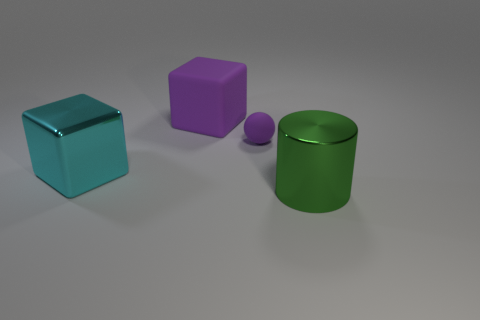What size is the cube that is the same color as the small matte object?
Your answer should be very brief. Large. How many large objects are either cyan blocks or blocks?
Make the answer very short. 2. Is the material of the tiny object the same as the cyan object?
Provide a succinct answer. No. There is a big cube that is behind the large cyan metal object; what number of purple rubber cubes are to the left of it?
Provide a short and direct response. 0. Is there a tiny gray thing of the same shape as the large purple matte thing?
Provide a succinct answer. No. There is a matte object behind the purple matte sphere; is its shape the same as the metallic object behind the big green cylinder?
Offer a very short reply. Yes. The thing that is on the right side of the large purple object and left of the shiny cylinder has what shape?
Make the answer very short. Sphere. Are there any purple matte things that have the same size as the green metallic thing?
Offer a terse response. Yes. Is the color of the sphere the same as the matte object that is left of the purple ball?
Offer a very short reply. Yes. What material is the small purple ball?
Offer a very short reply. Rubber. 